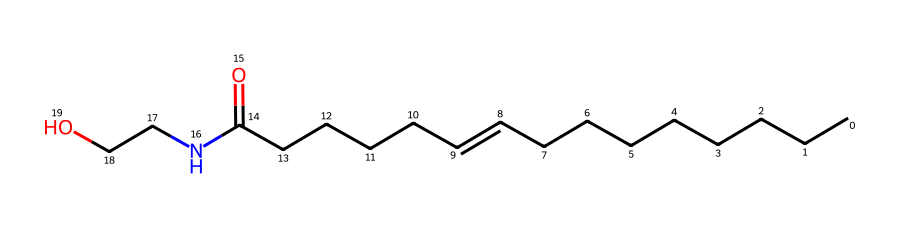What is the number of carbon atoms in this compound? Counting the carbon (C) atoms in the provided SMILES representation, there are a total of 18 carbon atoms present in the structure.
Answer: 18 How many oxygen atoms are in this chemical structure? Observing the SMILES representation, there are 2 oxygen (O) atoms, indicated by the "O" symbols within the structure.
Answer: 2 Is this chemical a saturated or unsaturated compound? The presence of a double bond ("=") in the carbon chain indicates that this compound is unsaturated due to the lack of hydrogen saturating the structure.
Answer: unsaturated What type of functional group is present in this drug? The presence of the "N" indicates an amine functional group (also the "C=O" indicates a carbonyl), suggesting that this compound contains amide characteristics associated with drugs.
Answer: amide What might be the primary pharmacological interaction of cannabinoids with this structure? Cannabinoids typically interact with the endocannabinoid system via CB1 and CB2 receptors, suggesting that this compound may influence these receptors due to its structural similarity to cannabinoids.
Answer: receptor modulation How does the presence of nitrogen affect the overall properties of this drug? The nitrogen atom adds basicity and potential for forming bonds with receptors, which can enhance the drug's efficacy as it interacts with biological systems.
Answer: increases basicity What effect does the carbonyl group have on the drug's solubility? The carbonyl (C=O) group can increase solubility in polar solvents due to its ability to form hydrogen bonds, allowing better interaction with aqueous environments.
Answer: increases solubility 